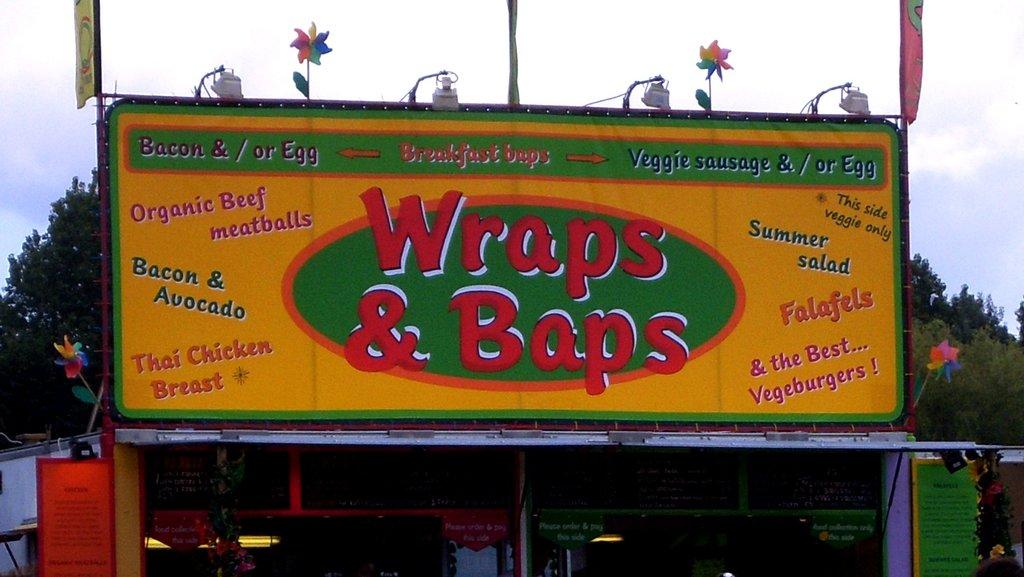What is only on the right side?
Ensure brevity in your answer.  Veggie. 